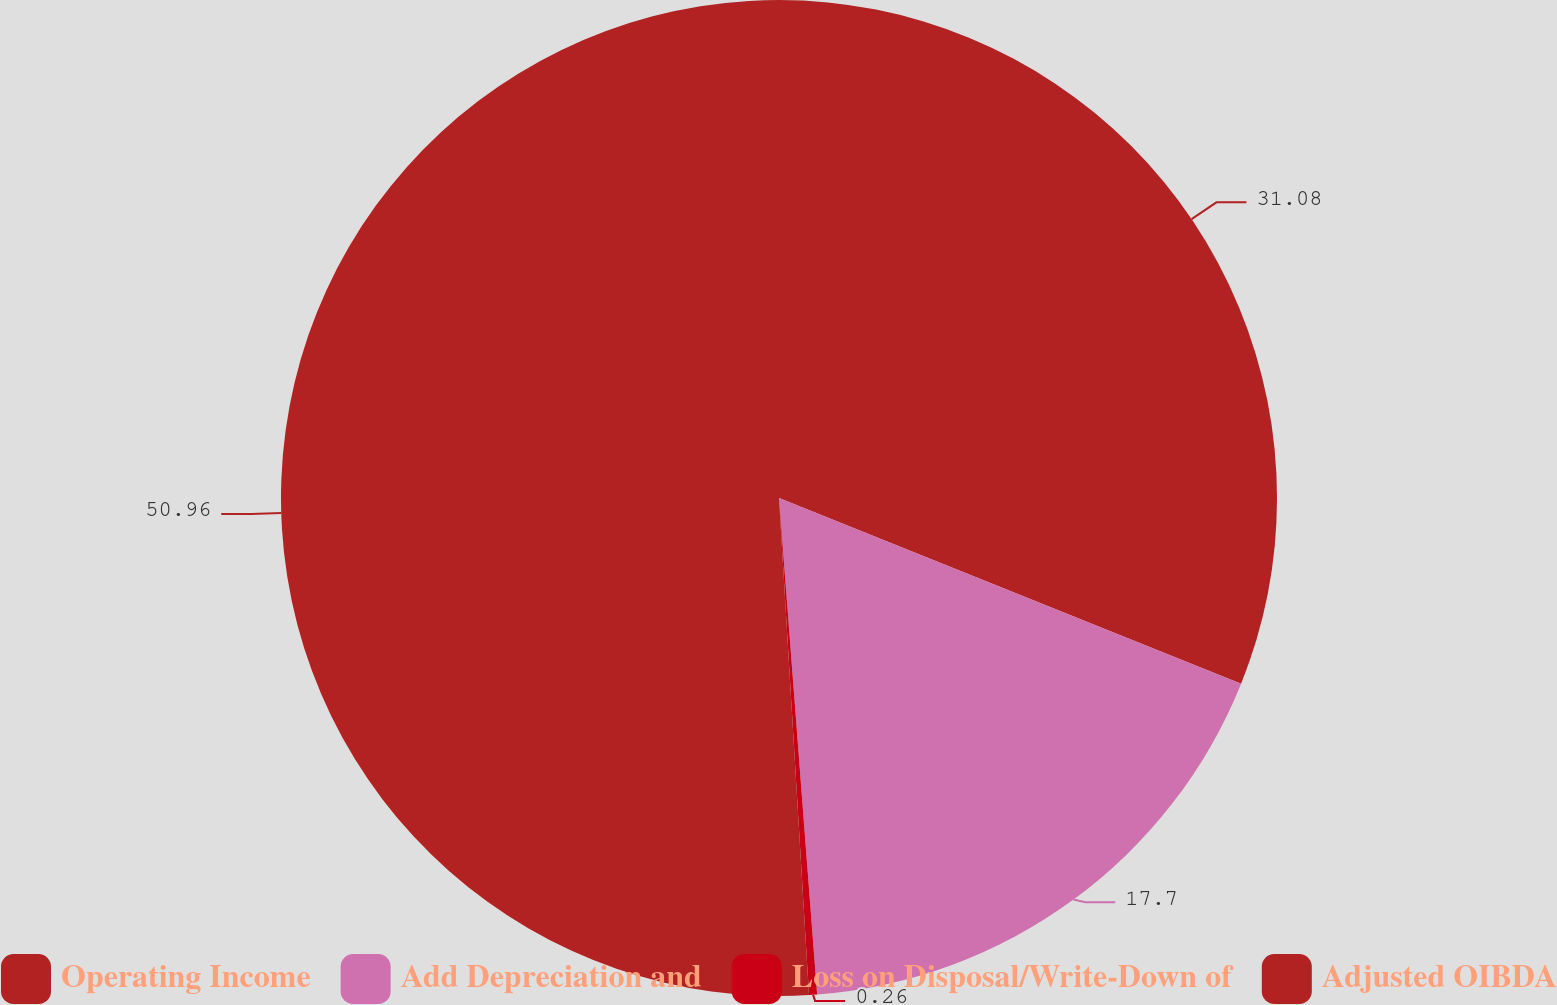Convert chart. <chart><loc_0><loc_0><loc_500><loc_500><pie_chart><fcel>Operating Income<fcel>Add Depreciation and<fcel>Loss on Disposal/Write-Down of<fcel>Adjusted OIBDA<nl><fcel>31.08%<fcel>17.7%<fcel>0.26%<fcel>50.96%<nl></chart> 